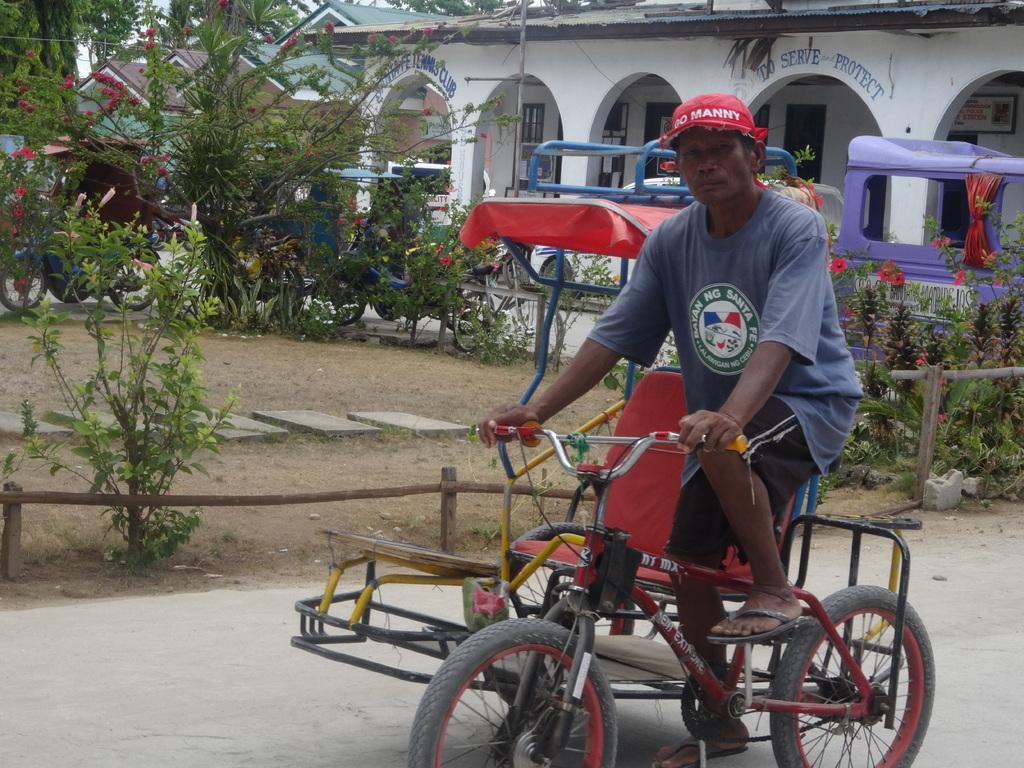In one or two sentences, can you explain what this image depicts? This picture is taken on the road where a man is riding a bicycle wearing red colour hat. In the background there are buildings, wall with the name written To serve protect. And there are plants and trees. 